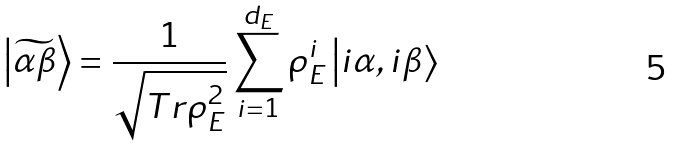<formula> <loc_0><loc_0><loc_500><loc_500>\left | \widetilde { \alpha \beta } \right \rangle = \frac { 1 } { \sqrt { T r \rho _ { E } ^ { 2 } } } \sum _ { i = 1 } ^ { d _ { E } } \rho _ { E } ^ { i } \left | i \alpha , i \beta \right \rangle</formula> 